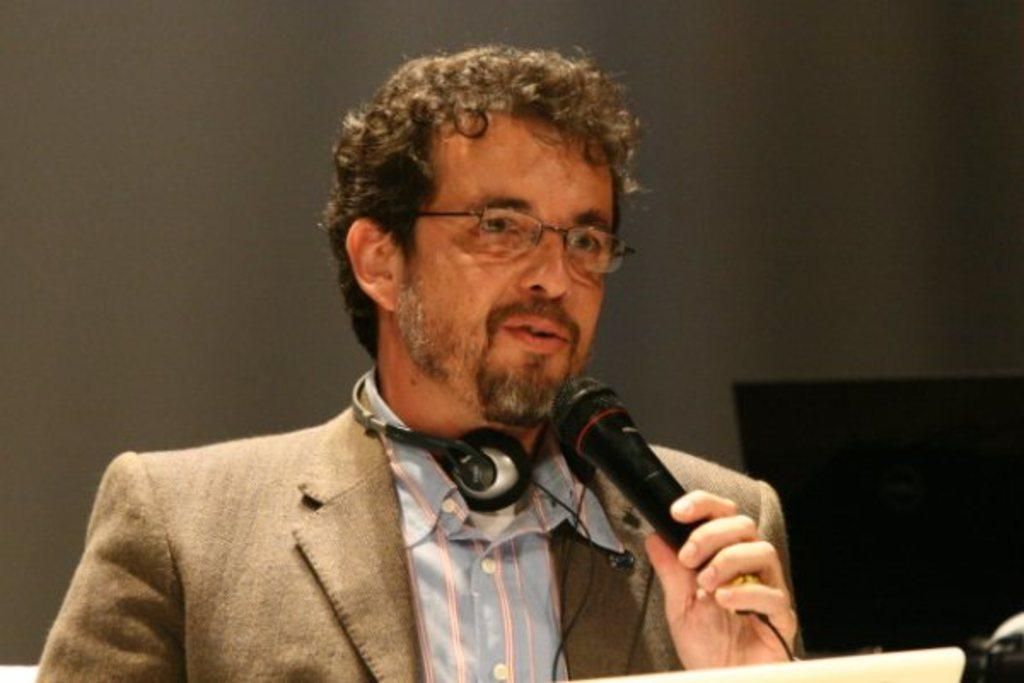Who is the main subject in the image? There is a man in the image. What is the man holding in the image? The man is holding a microphone. What is the man doing in the image? The man is talking. What can be seen in the background of the image? There is a wall in the background of the image. What type of calculator is the man wearing on his head in the image? There is no calculator present in the image, nor is the man wearing anything on his head. 